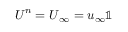<formula> <loc_0><loc_0><loc_500><loc_500>U ^ { n } = U _ { \infty } = u _ { \infty } \mathbb { 1 }</formula> 